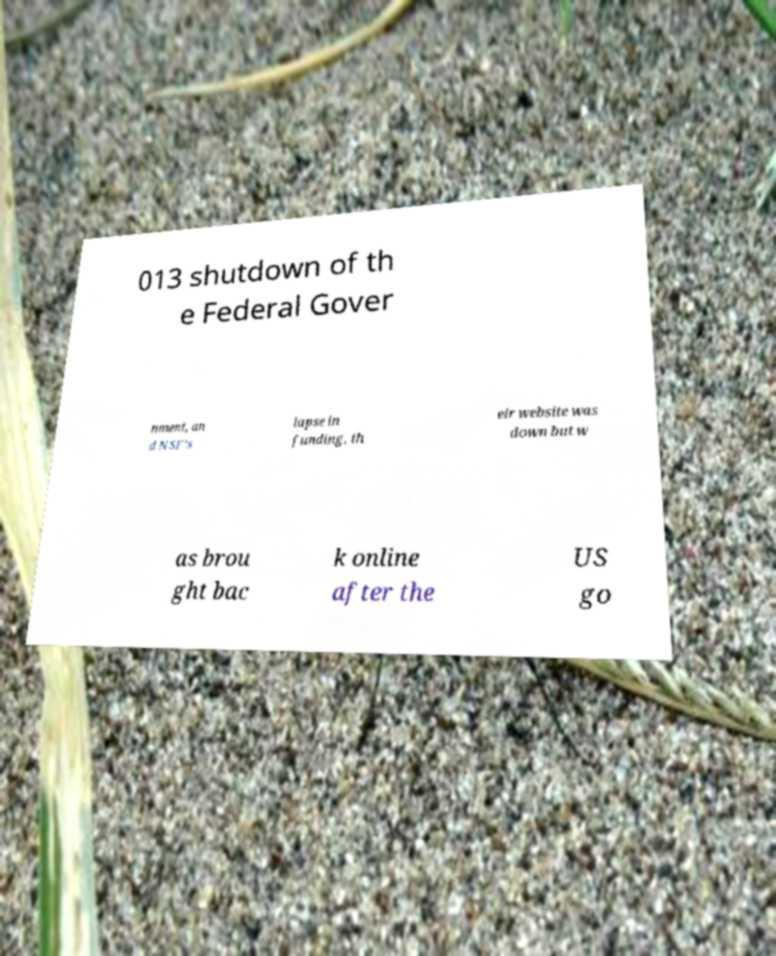Please read and relay the text visible in this image. What does it say? 013 shutdown of th e Federal Gover nment, an d NSF's lapse in funding, th eir website was down but w as brou ght bac k online after the US go 